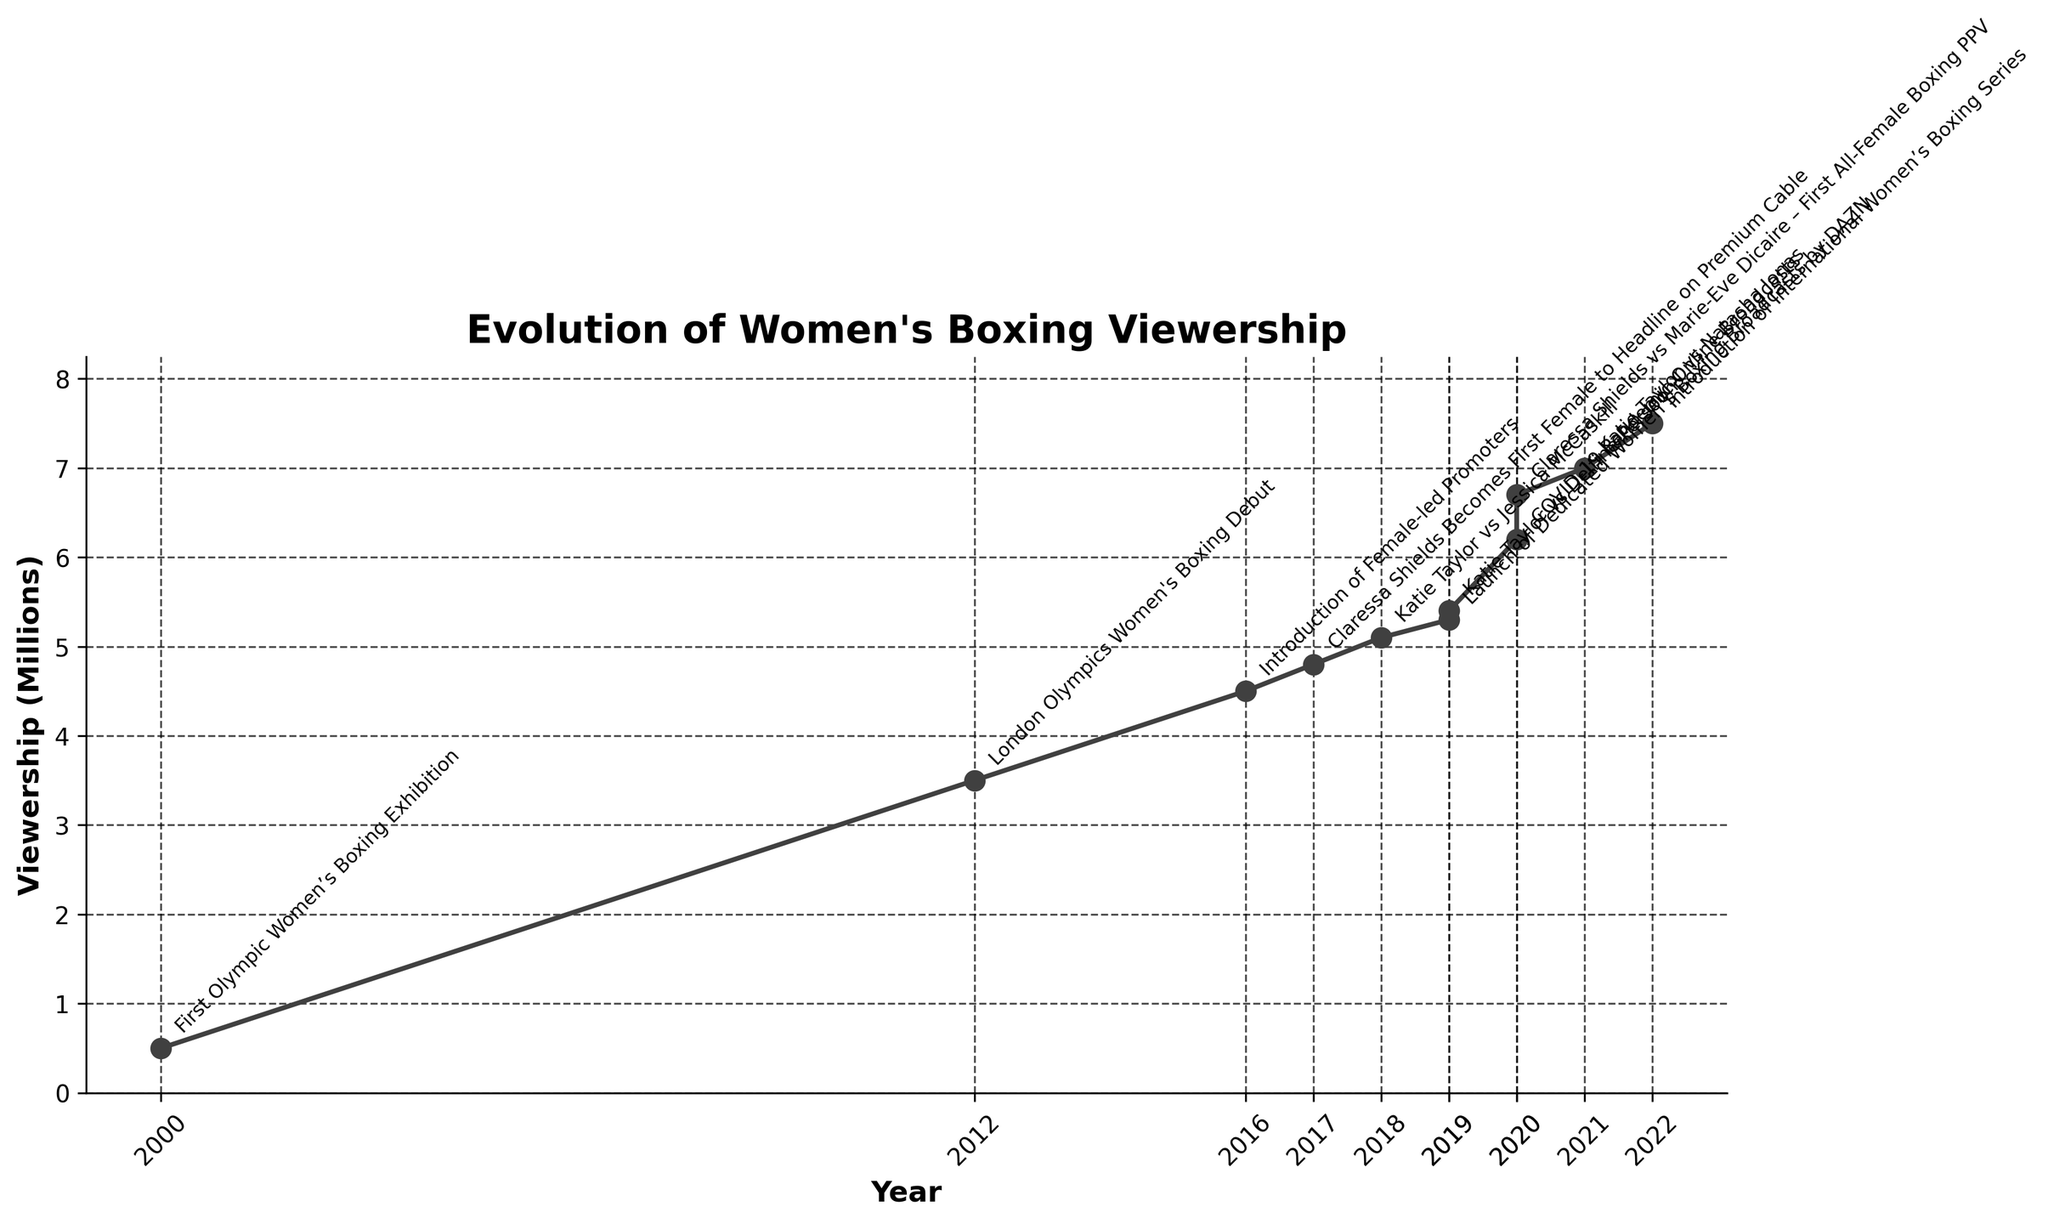What is the title of the plot? The title of the plot is visibly highlighted at the top of the figure.
Answer: Evolution of Women's Boxing Viewership How many major events in women's boxing are annotated on the plot? Each significant event in women's boxing, marked with an annotation, can be counted. The plot contains annotations for each event tagged with a note.
Answer: 11 What was the viewership for the "First All-Female Boxing PPV" event in 2020? Locate the annotation for "First All-Female Boxing PPV" in 2020 and read its corresponding viewership on the y-axis.
Answer: 6.7 million How did the viewership change from the "First Olympic Women's Boxing Exhibition" in 2000 to the "London Olympics Women's Boxing Debut" in 2012? Identify the viewership values for 2000 and 2012, then calculate the difference by subtracting the 2000 viewership from the 2012 viewership.
Answer: Increased by 3 million What is the general trend observed in the viewership of women's boxing from 2000 to 2022? Observing the trajectory of the plot line from 2000 to 2022, we can notice whether the line generally ascends or descends.
Answer: Increasing trend Which year witnessed the highest viewership according to the plot? By looking at the highest point on the y-axis and identifying the year corresponding to this peak.
Answer: 2022 How did the viewership change between "Katie Taylor vs Jessica McCaskill" and "Katie Taylor vs Delfine Persoon"? Identify the viewership values for both events in 2018 and 2019, respectively, and then calculate the difference.
Answer: Increased by 0.3 million What significant broadcasting shift occurred in 2020? Check the annotation for 2020 and note the event described.
Answer: Shift towards online streaming Which event marked a significant milestone in broadcasting in 2017? Read the annotation for the year 2017 and identify the event mentioned.
Answer: Claressa Shields Becomes First Female to Headline on Premium Cable 